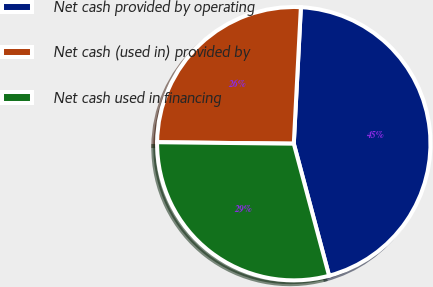Convert chart. <chart><loc_0><loc_0><loc_500><loc_500><pie_chart><fcel>Net cash provided by operating<fcel>Net cash (used in) provided by<fcel>Net cash used in financing<nl><fcel>45.02%<fcel>25.66%<fcel>29.33%<nl></chart> 